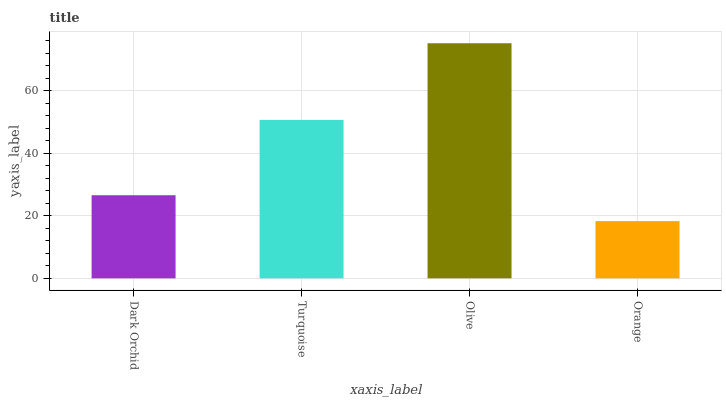Is Orange the minimum?
Answer yes or no. Yes. Is Olive the maximum?
Answer yes or no. Yes. Is Turquoise the minimum?
Answer yes or no. No. Is Turquoise the maximum?
Answer yes or no. No. Is Turquoise greater than Dark Orchid?
Answer yes or no. Yes. Is Dark Orchid less than Turquoise?
Answer yes or no. Yes. Is Dark Orchid greater than Turquoise?
Answer yes or no. No. Is Turquoise less than Dark Orchid?
Answer yes or no. No. Is Turquoise the high median?
Answer yes or no. Yes. Is Dark Orchid the low median?
Answer yes or no. Yes. Is Olive the high median?
Answer yes or no. No. Is Orange the low median?
Answer yes or no. No. 